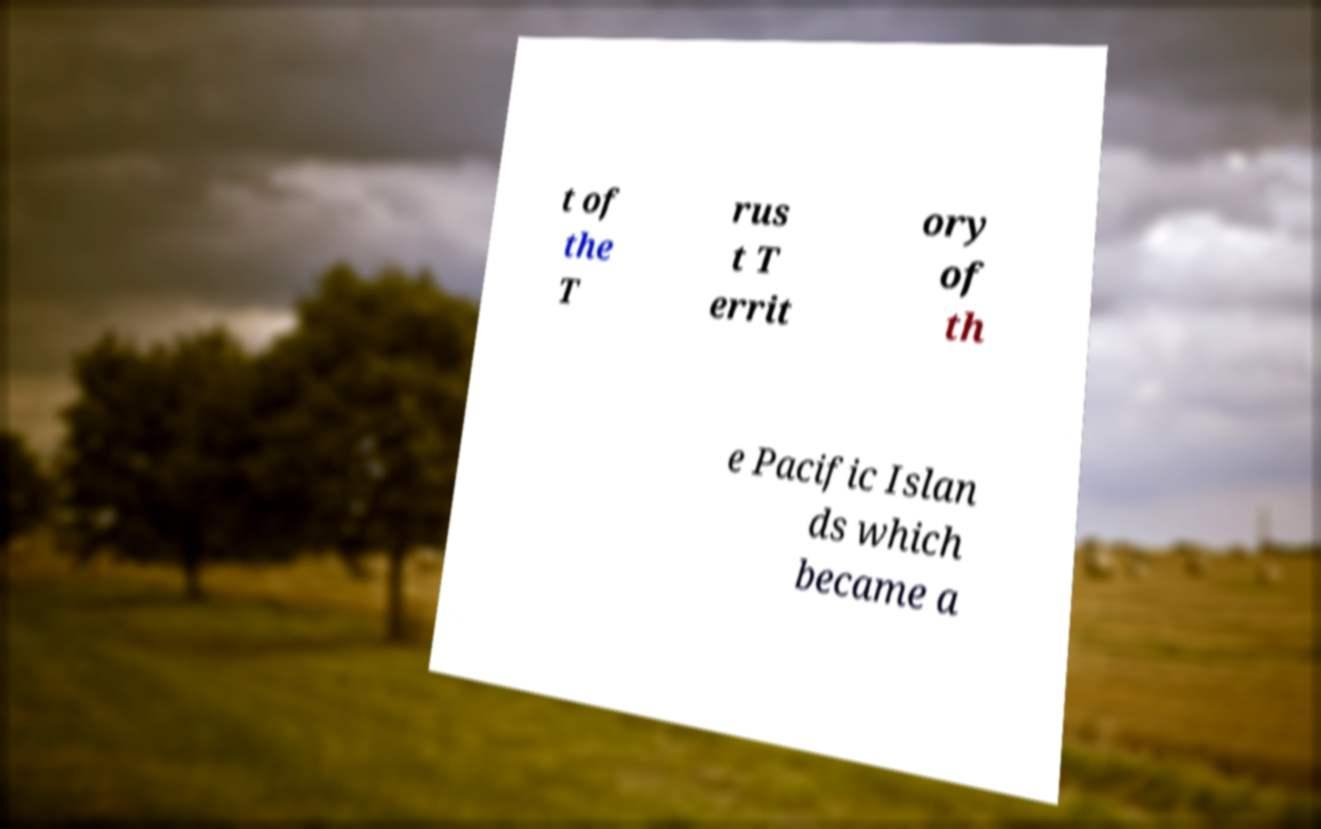Could you extract and type out the text from this image? t of the T rus t T errit ory of th e Pacific Islan ds which became a 